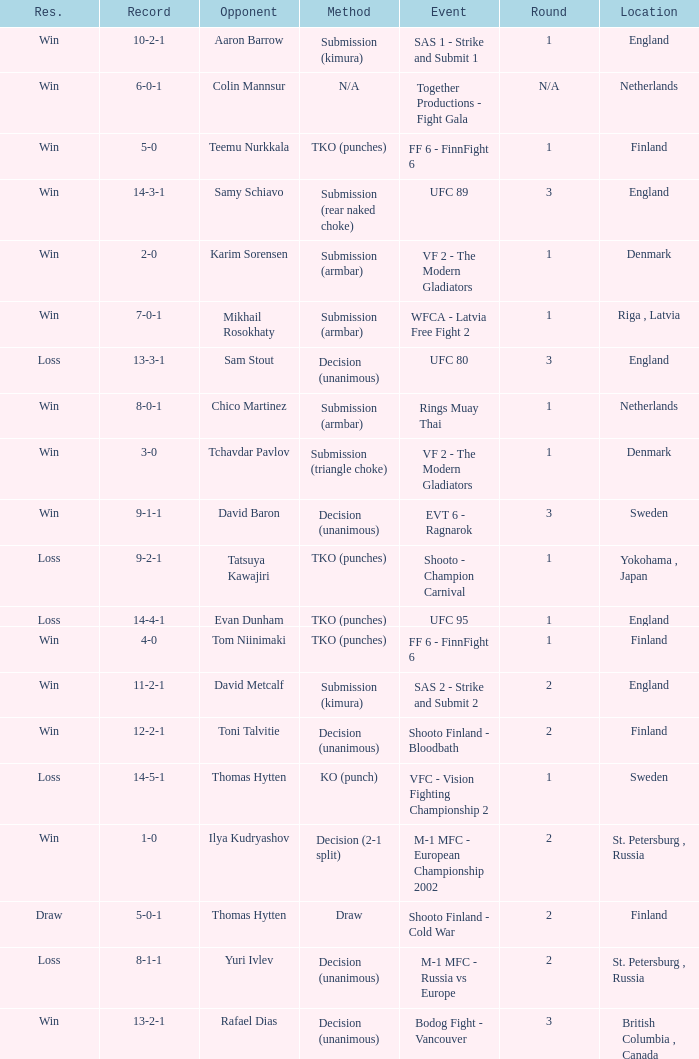What's the location when the record was 6-0-1? Netherlands. 